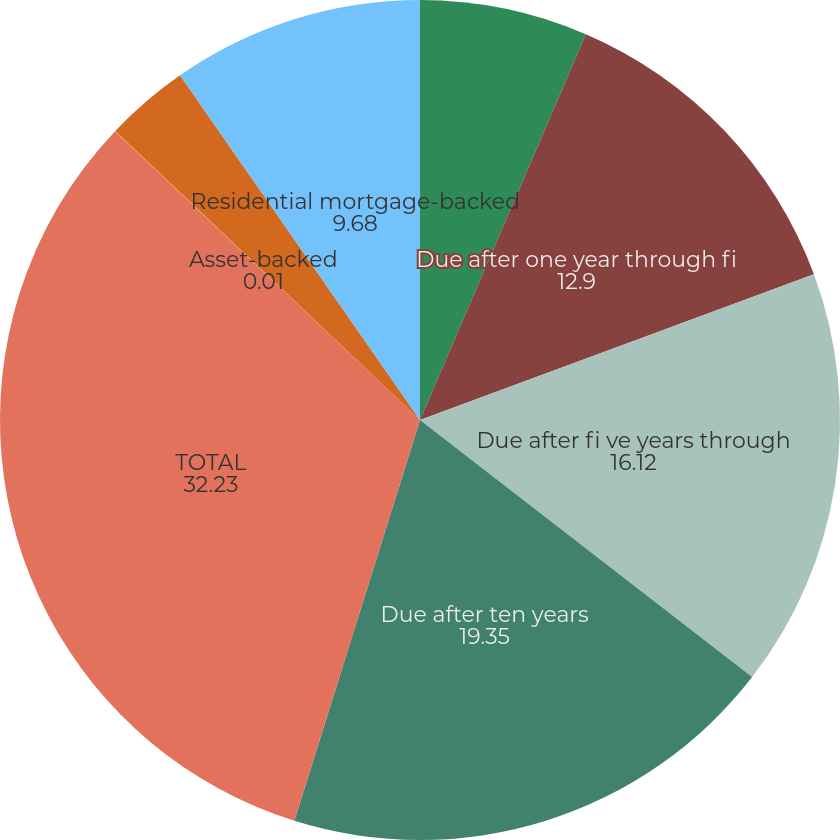<chart> <loc_0><loc_0><loc_500><loc_500><pie_chart><fcel>Due in one year or less<fcel>Due after one year through fi<fcel>Due after fi ve years through<fcel>Due after ten years<fcel>TOTAL<fcel>Asset-backed<fcel>Commercial mortgage-backed<fcel>Residential mortgage-backed<nl><fcel>6.46%<fcel>12.9%<fcel>16.12%<fcel>19.35%<fcel>32.23%<fcel>0.01%<fcel>3.24%<fcel>9.68%<nl></chart> 